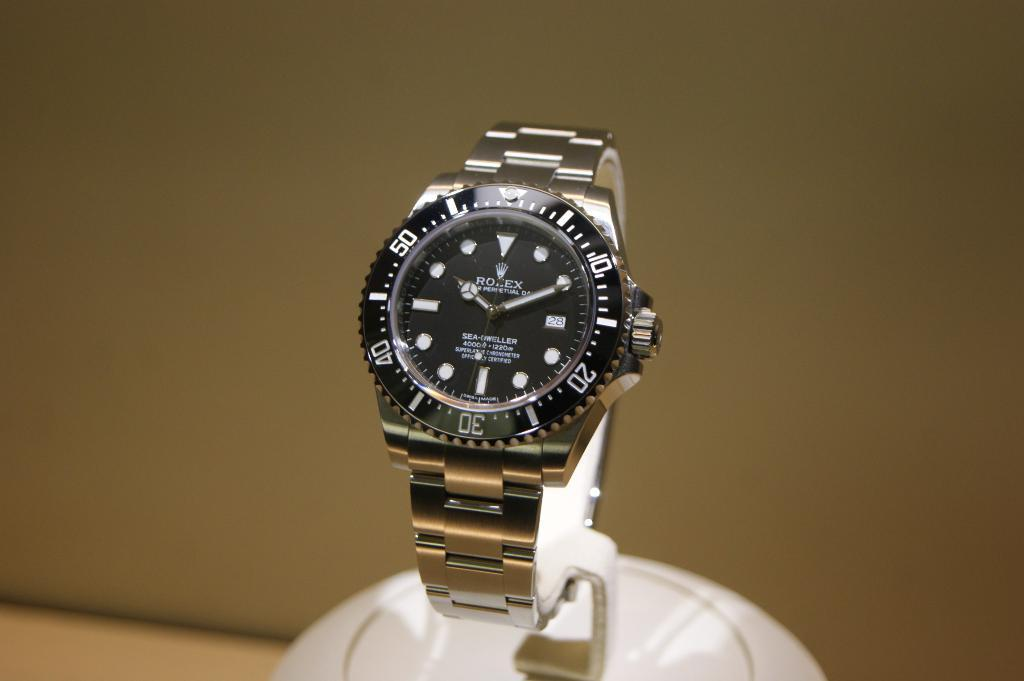<image>
Give a short and clear explanation of the subsequent image. a black an silver wristwatch with the brand rolex on its face. 